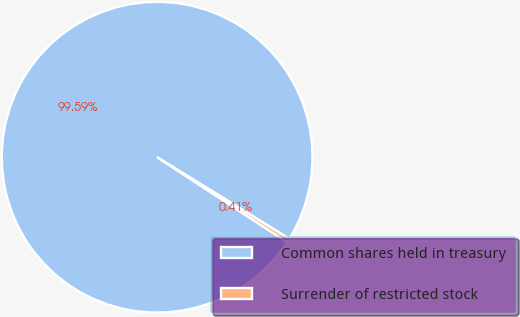<chart> <loc_0><loc_0><loc_500><loc_500><pie_chart><fcel>Common shares held in treasury<fcel>Surrender of restricted stock<nl><fcel>99.59%<fcel>0.41%<nl></chart> 